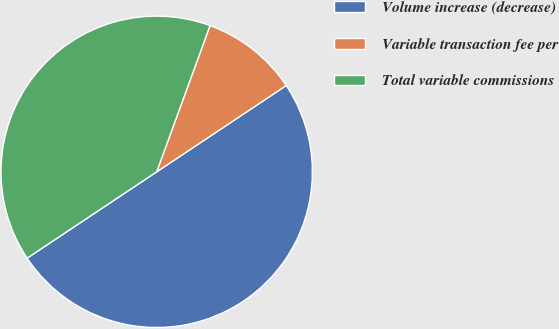<chart> <loc_0><loc_0><loc_500><loc_500><pie_chart><fcel>Volume increase (decrease)<fcel>Variable transaction fee per<fcel>Total variable commissions<nl><fcel>50.0%<fcel>10.08%<fcel>39.92%<nl></chart> 